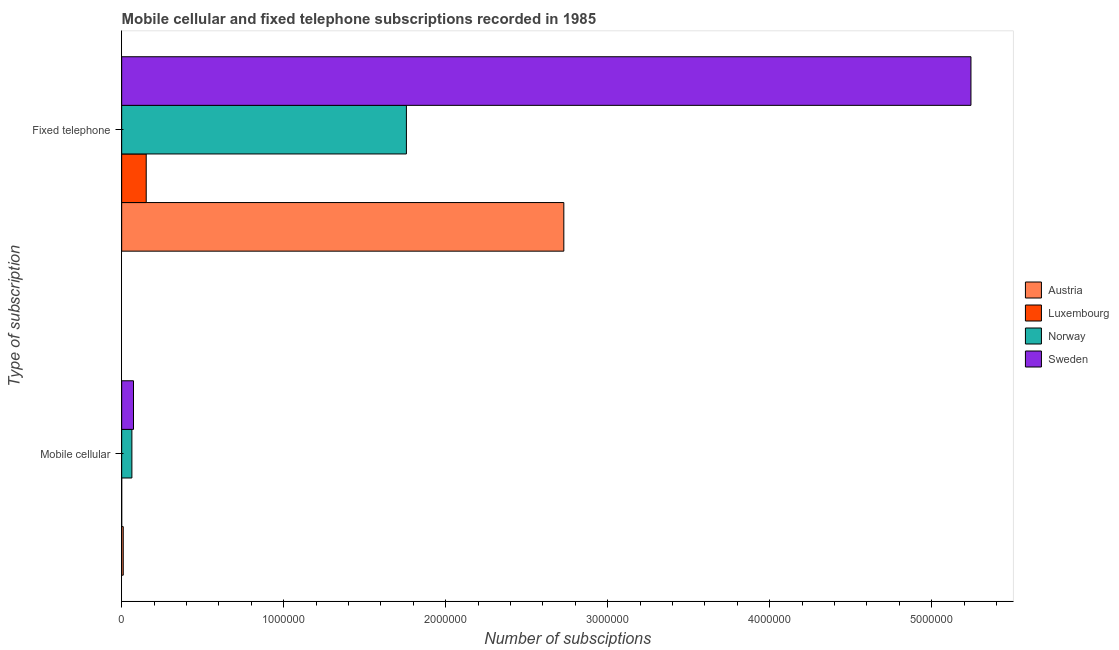How many groups of bars are there?
Keep it short and to the point. 2. Are the number of bars per tick equal to the number of legend labels?
Your response must be concise. Yes. How many bars are there on the 2nd tick from the top?
Your response must be concise. 4. What is the label of the 2nd group of bars from the top?
Offer a very short reply. Mobile cellular. What is the number of fixed telephone subscriptions in Sweden?
Offer a very short reply. 5.24e+06. Across all countries, what is the maximum number of mobile cellular subscriptions?
Keep it short and to the point. 7.30e+04. Across all countries, what is the minimum number of mobile cellular subscriptions?
Your answer should be very brief. 40. In which country was the number of mobile cellular subscriptions maximum?
Provide a short and direct response. Sweden. In which country was the number of fixed telephone subscriptions minimum?
Offer a very short reply. Luxembourg. What is the total number of fixed telephone subscriptions in the graph?
Keep it short and to the point. 9.88e+06. What is the difference between the number of fixed telephone subscriptions in Austria and that in Norway?
Offer a terse response. 9.72e+05. What is the difference between the number of fixed telephone subscriptions in Sweden and the number of mobile cellular subscriptions in Luxembourg?
Offer a very short reply. 5.24e+06. What is the average number of fixed telephone subscriptions per country?
Keep it short and to the point. 2.47e+06. What is the difference between the number of fixed telephone subscriptions and number of mobile cellular subscriptions in Austria?
Keep it short and to the point. 2.72e+06. In how many countries, is the number of fixed telephone subscriptions greater than 3600000 ?
Your answer should be compact. 1. What is the ratio of the number of mobile cellular subscriptions in Norway to that in Sweden?
Offer a terse response. 0.86. Is the number of fixed telephone subscriptions in Luxembourg less than that in Norway?
Your answer should be very brief. Yes. In how many countries, is the number of mobile cellular subscriptions greater than the average number of mobile cellular subscriptions taken over all countries?
Ensure brevity in your answer.  2. What does the 2nd bar from the bottom in Mobile cellular represents?
Provide a short and direct response. Luxembourg. Are the values on the major ticks of X-axis written in scientific E-notation?
Make the answer very short. No. Does the graph contain any zero values?
Make the answer very short. No. Does the graph contain grids?
Keep it short and to the point. No. How are the legend labels stacked?
Offer a very short reply. Vertical. What is the title of the graph?
Your response must be concise. Mobile cellular and fixed telephone subscriptions recorded in 1985. What is the label or title of the X-axis?
Provide a short and direct response. Number of subsciptions. What is the label or title of the Y-axis?
Provide a succinct answer. Type of subscription. What is the Number of subsciptions in Austria in Mobile cellular?
Give a very brief answer. 9762. What is the Number of subsciptions of Norway in Mobile cellular?
Provide a succinct answer. 6.31e+04. What is the Number of subsciptions in Sweden in Mobile cellular?
Offer a terse response. 7.30e+04. What is the Number of subsciptions in Austria in Fixed telephone?
Offer a terse response. 2.73e+06. What is the Number of subsciptions in Luxembourg in Fixed telephone?
Give a very brief answer. 1.52e+05. What is the Number of subsciptions of Norway in Fixed telephone?
Ensure brevity in your answer.  1.76e+06. What is the Number of subsciptions of Sweden in Fixed telephone?
Give a very brief answer. 5.24e+06. Across all Type of subscription, what is the maximum Number of subsciptions of Austria?
Offer a very short reply. 2.73e+06. Across all Type of subscription, what is the maximum Number of subsciptions in Luxembourg?
Provide a succinct answer. 1.52e+05. Across all Type of subscription, what is the maximum Number of subsciptions of Norway?
Provide a succinct answer. 1.76e+06. Across all Type of subscription, what is the maximum Number of subsciptions of Sweden?
Your answer should be very brief. 5.24e+06. Across all Type of subscription, what is the minimum Number of subsciptions of Austria?
Your answer should be very brief. 9762. Across all Type of subscription, what is the minimum Number of subsciptions in Luxembourg?
Your answer should be very brief. 40. Across all Type of subscription, what is the minimum Number of subsciptions of Norway?
Ensure brevity in your answer.  6.31e+04. Across all Type of subscription, what is the minimum Number of subsciptions of Sweden?
Your answer should be very brief. 7.30e+04. What is the total Number of subsciptions of Austria in the graph?
Your response must be concise. 2.74e+06. What is the total Number of subsciptions in Luxembourg in the graph?
Ensure brevity in your answer.  1.52e+05. What is the total Number of subsciptions in Norway in the graph?
Give a very brief answer. 1.82e+06. What is the total Number of subsciptions of Sweden in the graph?
Offer a very short reply. 5.32e+06. What is the difference between the Number of subsciptions in Austria in Mobile cellular and that in Fixed telephone?
Provide a short and direct response. -2.72e+06. What is the difference between the Number of subsciptions in Luxembourg in Mobile cellular and that in Fixed telephone?
Keep it short and to the point. -1.51e+05. What is the difference between the Number of subsciptions of Norway in Mobile cellular and that in Fixed telephone?
Offer a very short reply. -1.69e+06. What is the difference between the Number of subsciptions of Sweden in Mobile cellular and that in Fixed telephone?
Your answer should be very brief. -5.17e+06. What is the difference between the Number of subsciptions of Austria in Mobile cellular and the Number of subsciptions of Luxembourg in Fixed telephone?
Ensure brevity in your answer.  -1.42e+05. What is the difference between the Number of subsciptions of Austria in Mobile cellular and the Number of subsciptions of Norway in Fixed telephone?
Keep it short and to the point. -1.75e+06. What is the difference between the Number of subsciptions in Austria in Mobile cellular and the Number of subsciptions in Sweden in Fixed telephone?
Your answer should be very brief. -5.23e+06. What is the difference between the Number of subsciptions of Luxembourg in Mobile cellular and the Number of subsciptions of Norway in Fixed telephone?
Offer a terse response. -1.76e+06. What is the difference between the Number of subsciptions in Luxembourg in Mobile cellular and the Number of subsciptions in Sweden in Fixed telephone?
Keep it short and to the point. -5.24e+06. What is the difference between the Number of subsciptions in Norway in Mobile cellular and the Number of subsciptions in Sweden in Fixed telephone?
Provide a succinct answer. -5.18e+06. What is the average Number of subsciptions in Austria per Type of subscription?
Give a very brief answer. 1.37e+06. What is the average Number of subsciptions in Luxembourg per Type of subscription?
Your answer should be compact. 7.58e+04. What is the average Number of subsciptions of Norway per Type of subscription?
Your response must be concise. 9.10e+05. What is the average Number of subsciptions of Sweden per Type of subscription?
Keep it short and to the point. 2.66e+06. What is the difference between the Number of subsciptions of Austria and Number of subsciptions of Luxembourg in Mobile cellular?
Provide a short and direct response. 9722. What is the difference between the Number of subsciptions in Austria and Number of subsciptions in Norway in Mobile cellular?
Give a very brief answer. -5.33e+04. What is the difference between the Number of subsciptions in Austria and Number of subsciptions in Sweden in Mobile cellular?
Keep it short and to the point. -6.32e+04. What is the difference between the Number of subsciptions of Luxembourg and Number of subsciptions of Norway in Mobile cellular?
Offer a very short reply. -6.30e+04. What is the difference between the Number of subsciptions of Luxembourg and Number of subsciptions of Sweden in Mobile cellular?
Ensure brevity in your answer.  -7.30e+04. What is the difference between the Number of subsciptions in Norway and Number of subsciptions in Sweden in Mobile cellular?
Offer a very short reply. -9925. What is the difference between the Number of subsciptions in Austria and Number of subsciptions in Luxembourg in Fixed telephone?
Your answer should be compact. 2.58e+06. What is the difference between the Number of subsciptions in Austria and Number of subsciptions in Norway in Fixed telephone?
Your response must be concise. 9.72e+05. What is the difference between the Number of subsciptions in Austria and Number of subsciptions in Sweden in Fixed telephone?
Ensure brevity in your answer.  -2.51e+06. What is the difference between the Number of subsciptions in Luxembourg and Number of subsciptions in Norway in Fixed telephone?
Your response must be concise. -1.61e+06. What is the difference between the Number of subsciptions in Luxembourg and Number of subsciptions in Sweden in Fixed telephone?
Provide a short and direct response. -5.09e+06. What is the difference between the Number of subsciptions in Norway and Number of subsciptions in Sweden in Fixed telephone?
Provide a succinct answer. -3.48e+06. What is the ratio of the Number of subsciptions of Austria in Mobile cellular to that in Fixed telephone?
Give a very brief answer. 0. What is the ratio of the Number of subsciptions of Norway in Mobile cellular to that in Fixed telephone?
Offer a terse response. 0.04. What is the ratio of the Number of subsciptions of Sweden in Mobile cellular to that in Fixed telephone?
Ensure brevity in your answer.  0.01. What is the difference between the highest and the second highest Number of subsciptions in Austria?
Offer a very short reply. 2.72e+06. What is the difference between the highest and the second highest Number of subsciptions in Luxembourg?
Offer a very short reply. 1.51e+05. What is the difference between the highest and the second highest Number of subsciptions of Norway?
Provide a succinct answer. 1.69e+06. What is the difference between the highest and the second highest Number of subsciptions of Sweden?
Provide a succinct answer. 5.17e+06. What is the difference between the highest and the lowest Number of subsciptions of Austria?
Ensure brevity in your answer.  2.72e+06. What is the difference between the highest and the lowest Number of subsciptions in Luxembourg?
Your answer should be compact. 1.51e+05. What is the difference between the highest and the lowest Number of subsciptions in Norway?
Provide a succinct answer. 1.69e+06. What is the difference between the highest and the lowest Number of subsciptions in Sweden?
Ensure brevity in your answer.  5.17e+06. 